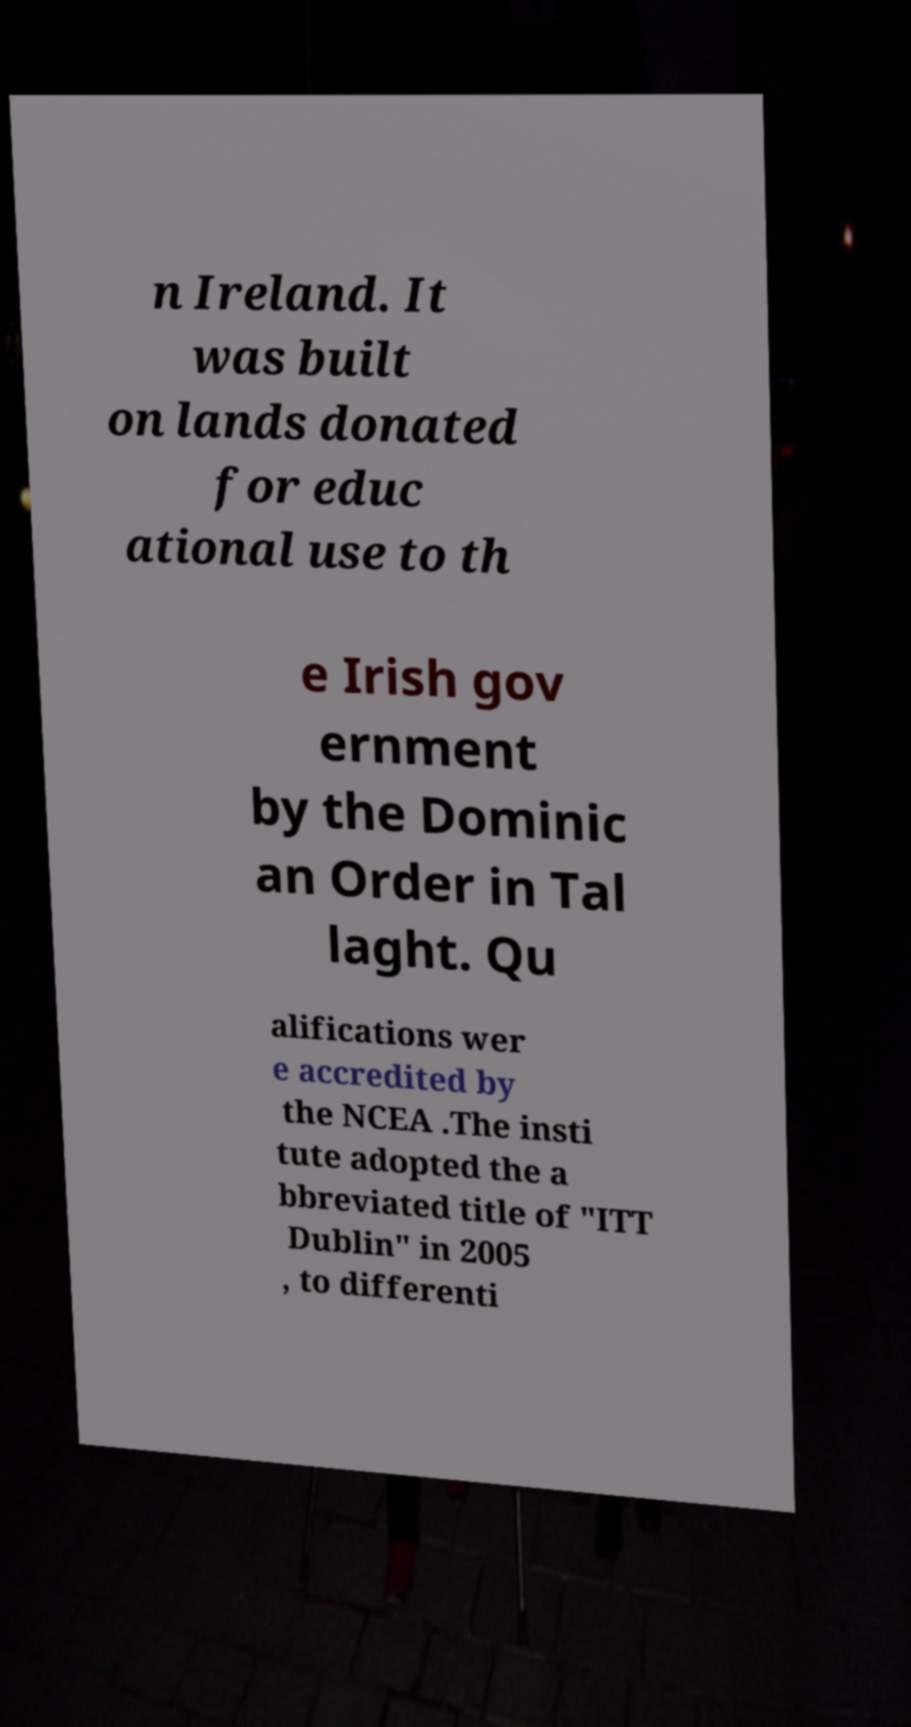I need the written content from this picture converted into text. Can you do that? n Ireland. It was built on lands donated for educ ational use to th e Irish gov ernment by the Dominic an Order in Tal laght. Qu alifications wer e accredited by the NCEA .The insti tute adopted the a bbreviated title of "ITT Dublin" in 2005 , to differenti 